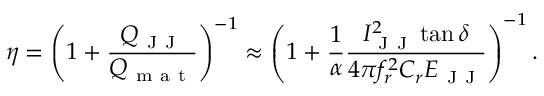Convert formula to latex. <formula><loc_0><loc_0><loc_500><loc_500>\eta = \left ( 1 + \frac { Q _ { J J } } { Q _ { m a t } } \right ) ^ { - 1 } \approx \left ( 1 + \frac { 1 } { \alpha } \frac { I _ { J J } ^ { 2 } \tan { \delta } } { 4 \pi f _ { r } ^ { 2 } C _ { r } E _ { J J } } \right ) ^ { - 1 } .</formula> 